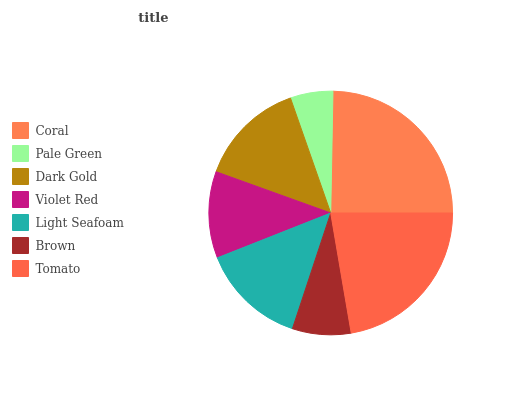Is Pale Green the minimum?
Answer yes or no. Yes. Is Coral the maximum?
Answer yes or no. Yes. Is Dark Gold the minimum?
Answer yes or no. No. Is Dark Gold the maximum?
Answer yes or no. No. Is Dark Gold greater than Pale Green?
Answer yes or no. Yes. Is Pale Green less than Dark Gold?
Answer yes or no. Yes. Is Pale Green greater than Dark Gold?
Answer yes or no. No. Is Dark Gold less than Pale Green?
Answer yes or no. No. Is Light Seafoam the high median?
Answer yes or no. Yes. Is Light Seafoam the low median?
Answer yes or no. Yes. Is Brown the high median?
Answer yes or no. No. Is Pale Green the low median?
Answer yes or no. No. 